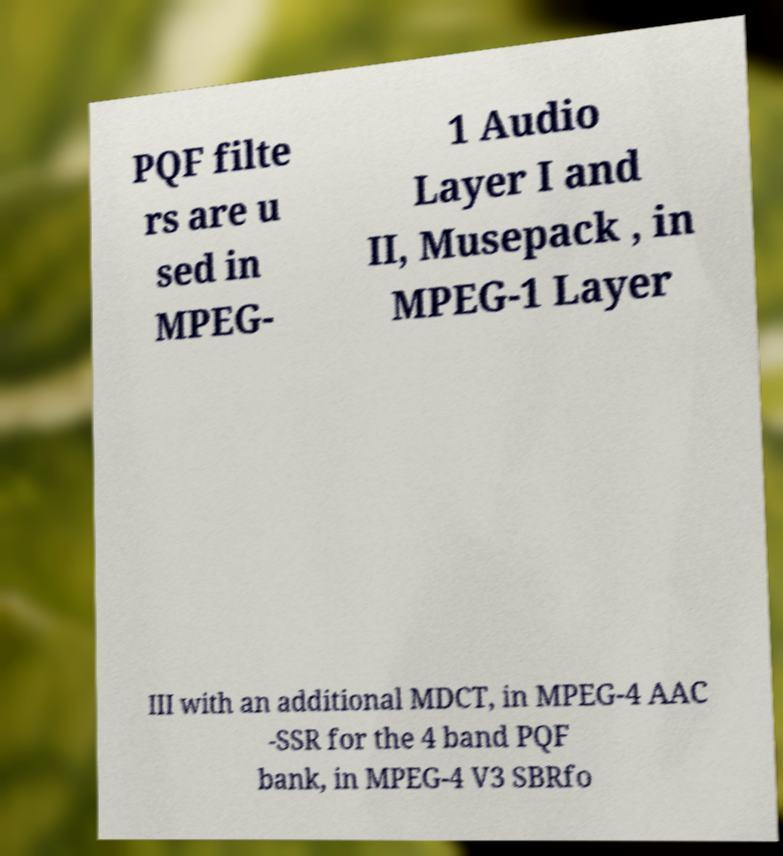Could you assist in decoding the text presented in this image and type it out clearly? PQF filte rs are u sed in MPEG- 1 Audio Layer I and II, Musepack , in MPEG-1 Layer III with an additional MDCT, in MPEG-4 AAC -SSR for the 4 band PQF bank, in MPEG-4 V3 SBRfo 